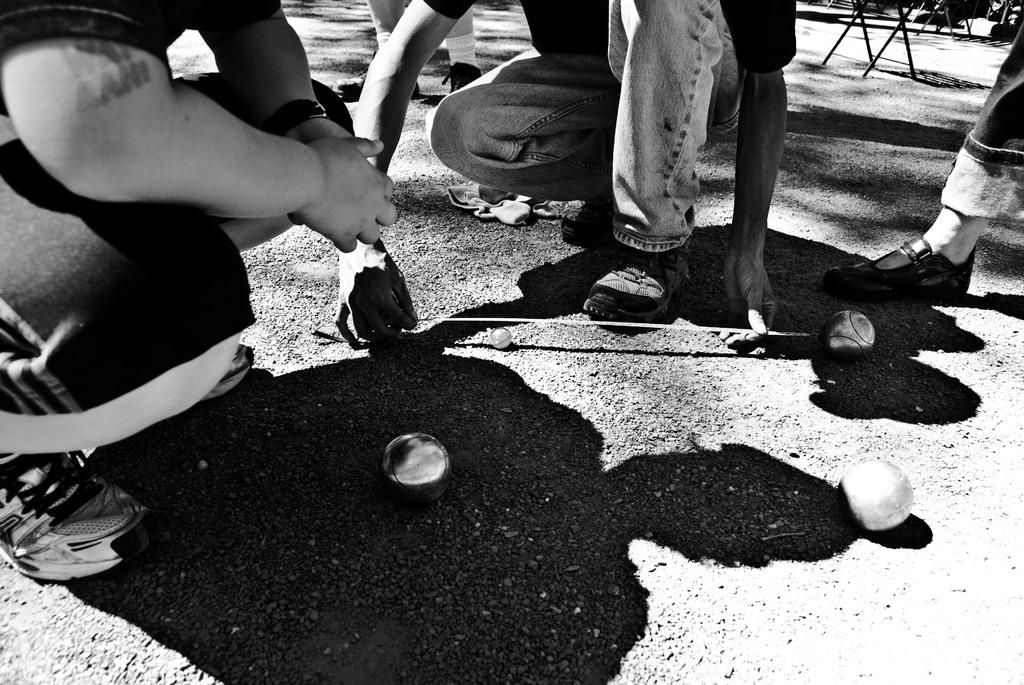What is the color scheme of the image? The image is black and white. What can be seen in the image besides the color scheme? There are persons and balls on the surface in the image. What type of bird can be seen flying in the image? There are no birds visible in the image, as it is black and white and only features persons and balls on the surface. 